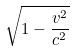<formula> <loc_0><loc_0><loc_500><loc_500>\sqrt { 1 - \frac { v ^ { 2 } } { c ^ { 2 } } }</formula> 